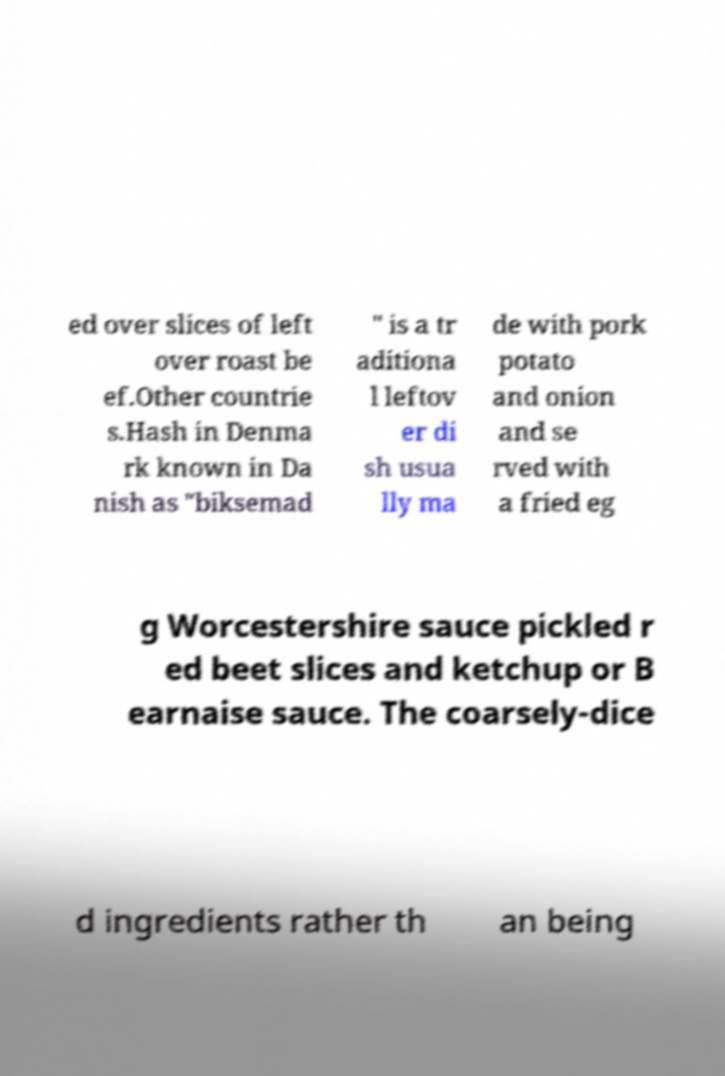There's text embedded in this image that I need extracted. Can you transcribe it verbatim? ed over slices of left over roast be ef.Other countrie s.Hash in Denma rk known in Da nish as "biksemad " is a tr aditiona l leftov er di sh usua lly ma de with pork potato and onion and se rved with a fried eg g Worcestershire sauce pickled r ed beet slices and ketchup or B earnaise sauce. The coarsely-dice d ingredients rather th an being 